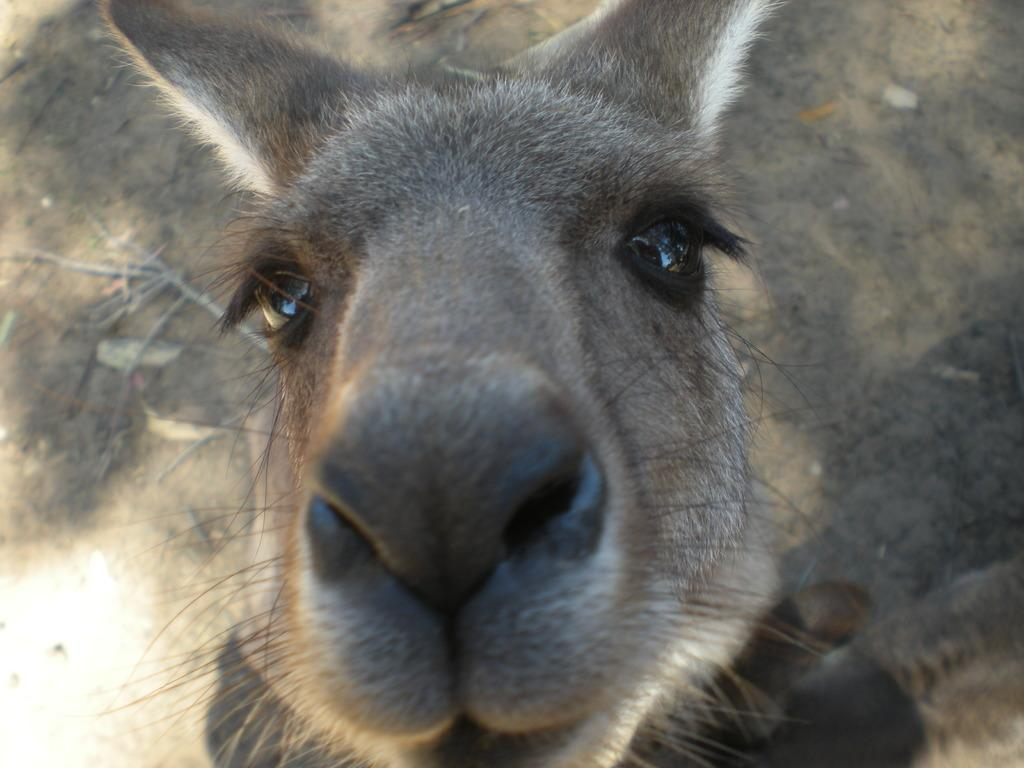What animal is in the center of the image? There is a donkey in the center of the image. What type of surface can be seen in the background of the image? There is ground visible in the background of the image. What type of writing instrument is the donkey holding in the image? The donkey is not holding any writing instrument in the image; it is an animal and does not use such tools. 